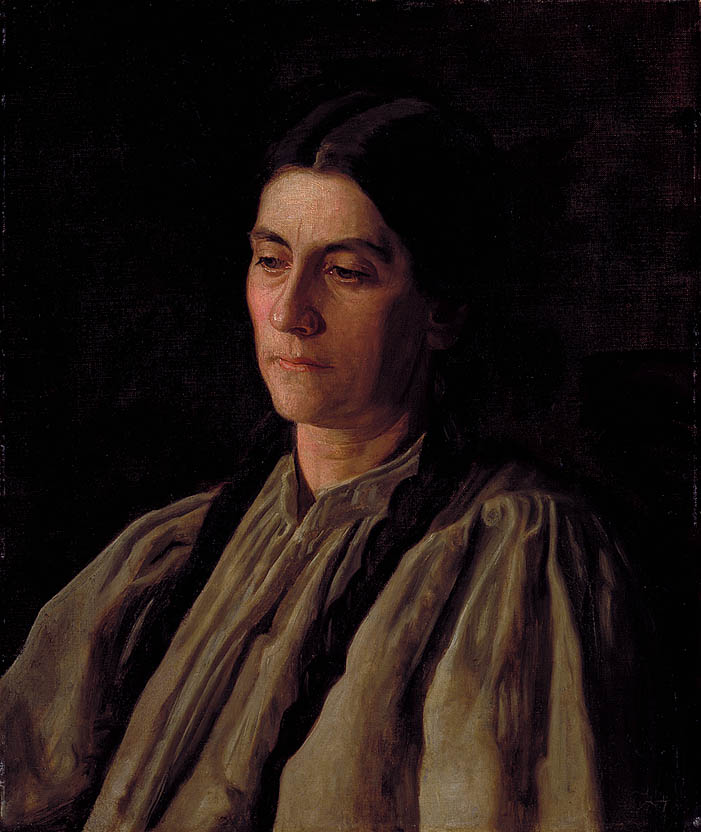What is this photo about'? The image is a portrait of a woman, painted in an impressionist style. The background is dark, serving to highlight the subject of the portrait. The woman is wearing a light-colored blouse with a high collar, which stands out against the darker elements of the painting. A dark-colored shawl is draped over her shoulders, complementing her blouse. The blouse has a loose fit, adding a sense of casual elegance to her attire. Her hair is neatly parted in the middle and pulled back, revealing her face clearly. The loose brushstrokes and the play of light and shadow are characteristic of the impressionist style. The colors used in the painting are mostly dark and muted, with the exception of the woman's blouse which is a light cream color. The overall mood of the portrait is somber and contemplative. 